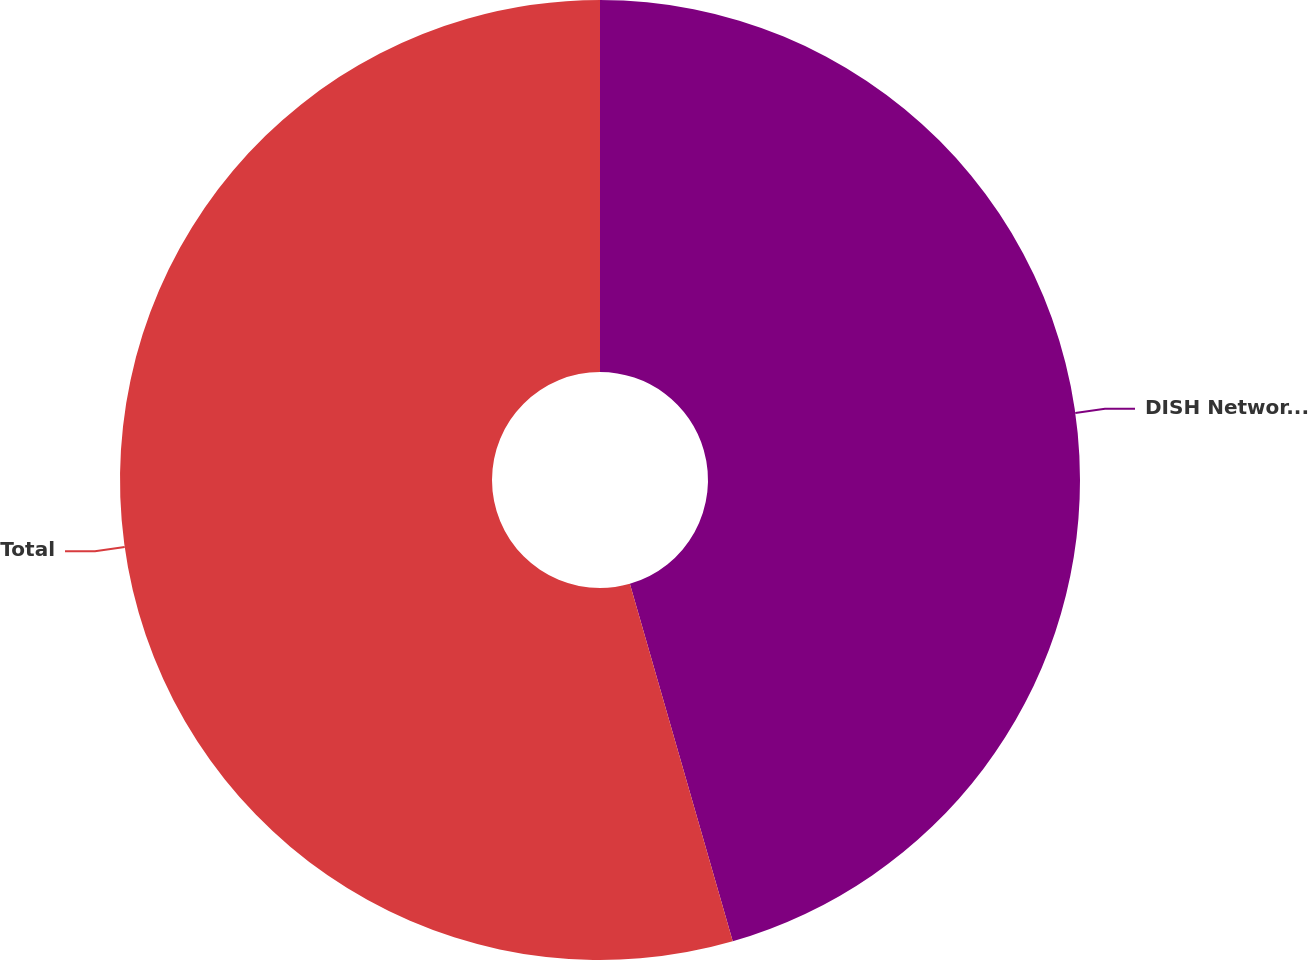Convert chart. <chart><loc_0><loc_0><loc_500><loc_500><pie_chart><fcel>DISH Network awards held by<fcel>Total<nl><fcel>45.54%<fcel>54.46%<nl></chart> 